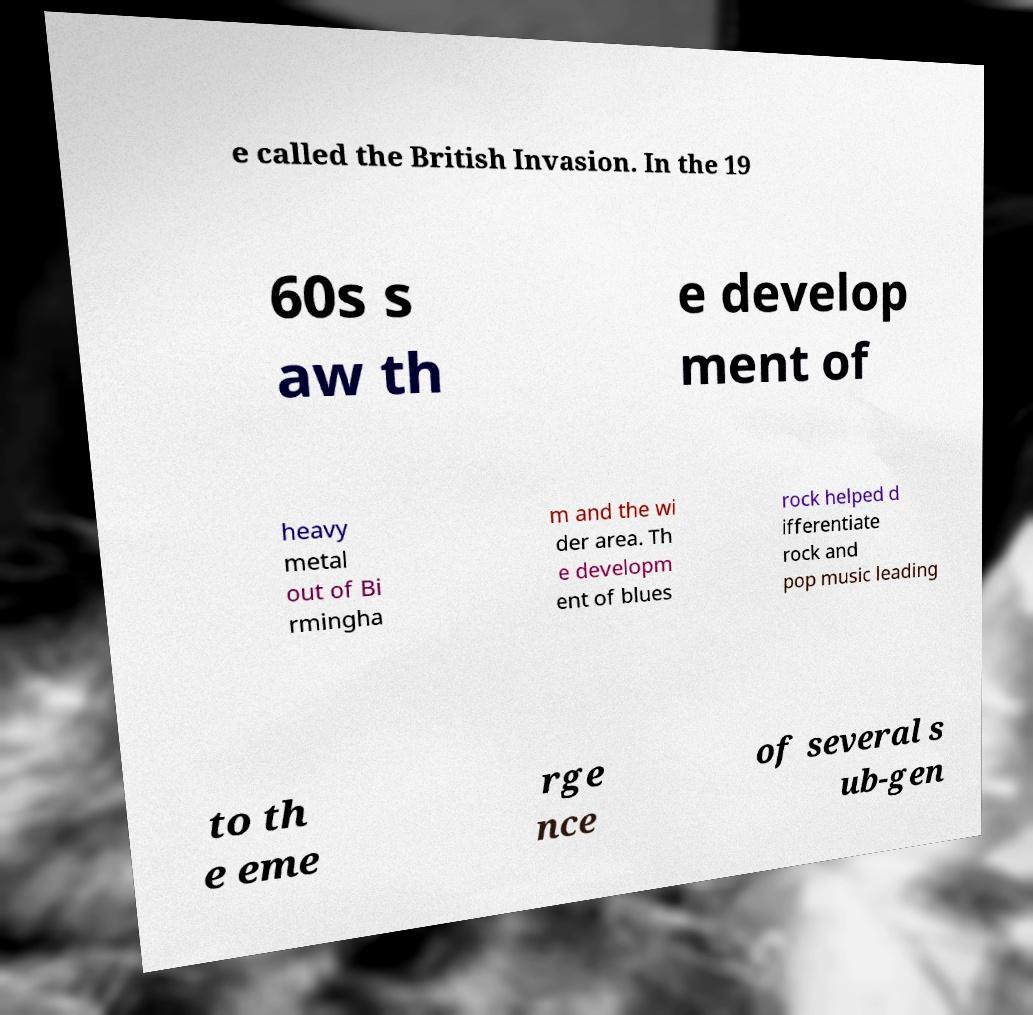Can you read and provide the text displayed in the image?This photo seems to have some interesting text. Can you extract and type it out for me? e called the British Invasion. In the 19 60s s aw th e develop ment of heavy metal out of Bi rmingha m and the wi der area. Th e developm ent of blues rock helped d ifferentiate rock and pop music leading to th e eme rge nce of several s ub-gen 